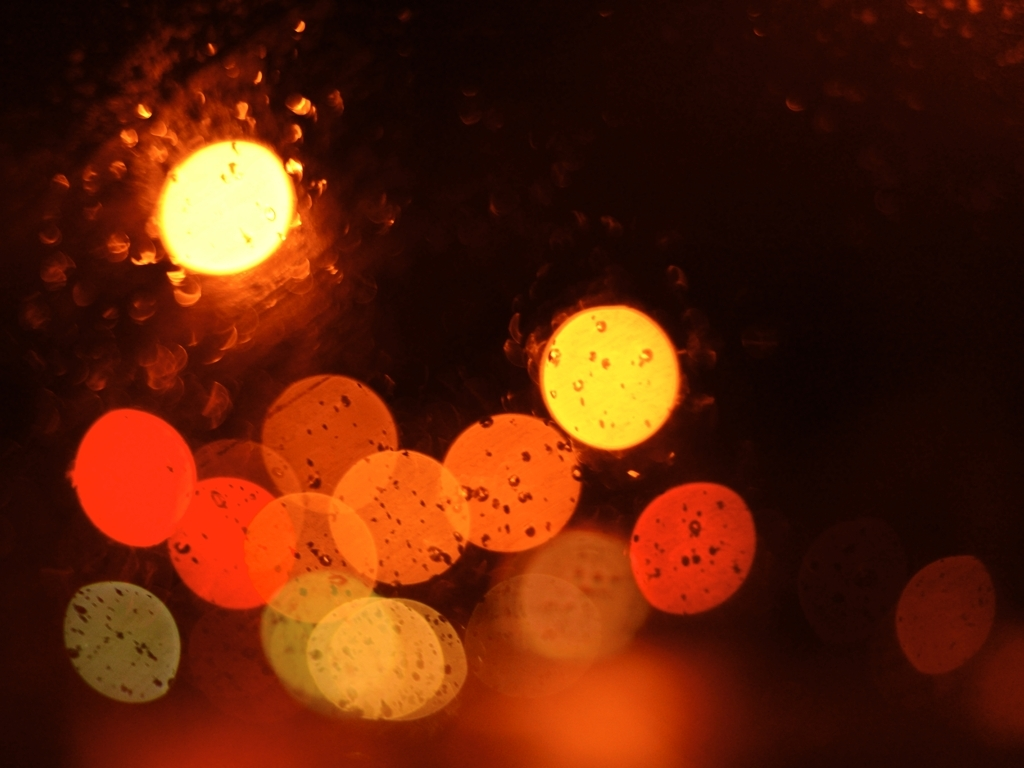Can you suggest a setting or mood that this image might evoke? The warm hues and gentle diffusion of light evoke a sense of coziness and intimacy, possibly reminiscent of a rainy evening indoors. It might suggest a mood of contemplation or the warmth of urban life contrasted with the natural element of rain. 